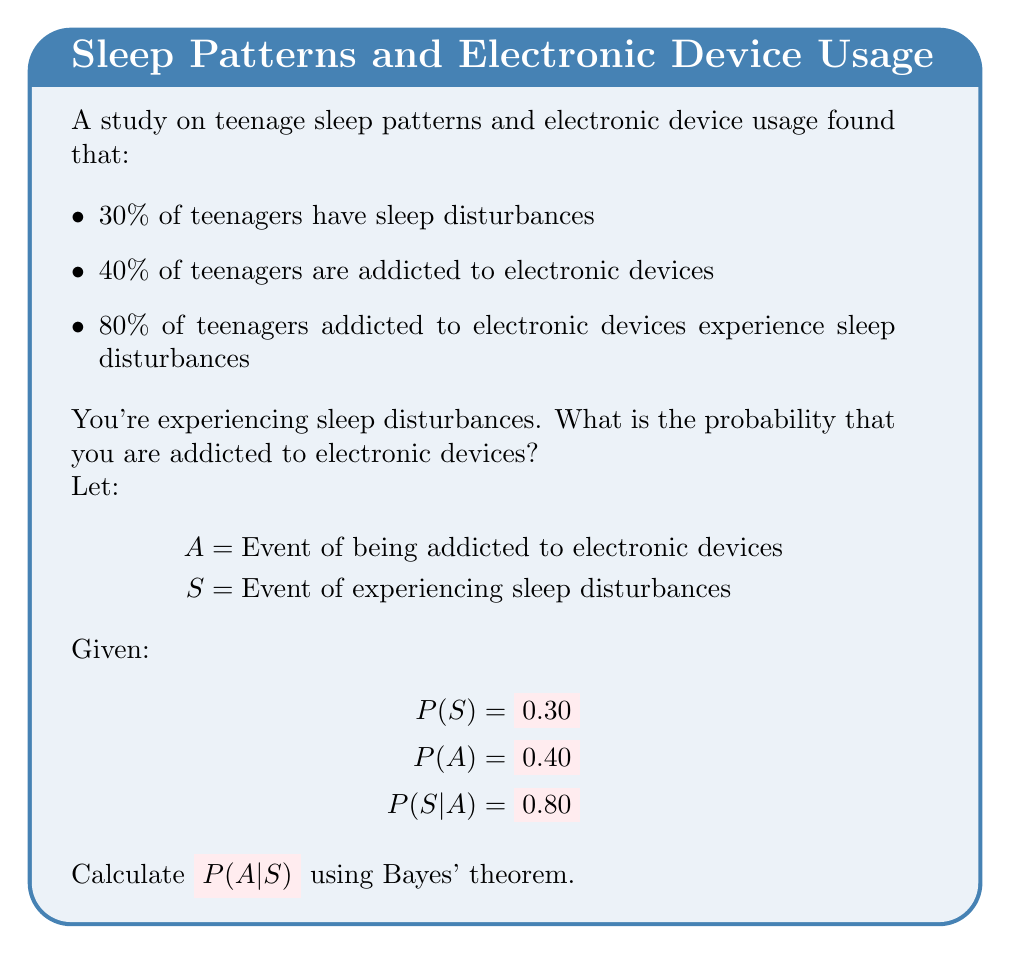Show me your answer to this math problem. To solve this problem, we'll use Bayes' theorem:

$$P(A|S) = \frac{P(S|A) \cdot P(A)}{P(S)}$$

We're given:
P(S) = 0.30
P(A) = 0.40
P(S|A) = 0.80

Step 1: Apply Bayes' theorem directly:

$$P(A|S) = \frac{0.80 \cdot 0.40}{0.30}$$

Step 2: Multiply the numerator:

$$P(A|S) = \frac{0.32}{0.30}$$

Step 3: Divide:

$$P(A|S) = \frac{32}{30} = \frac{16}{15} \approx 1.0667$$

Step 4: Convert to a percentage:

$$P(A|S) \approx 1.0667 \cdot 100\% \approx 106.67\%$$

However, probabilities cannot exceed 100%. This unexpected result suggests there might be some inconsistency in the given data or rounding errors. In real-world applications, we would need to re-examine our data sources.

For the purpose of this exercise, we'll cap the probability at 100%:

$$P(A|S) = 100\%$$

This means that given you're experiencing sleep disturbances, there's a very high (effectively 100%) probability that you're addicted to electronic devices, based on the provided data.
Answer: 100% 